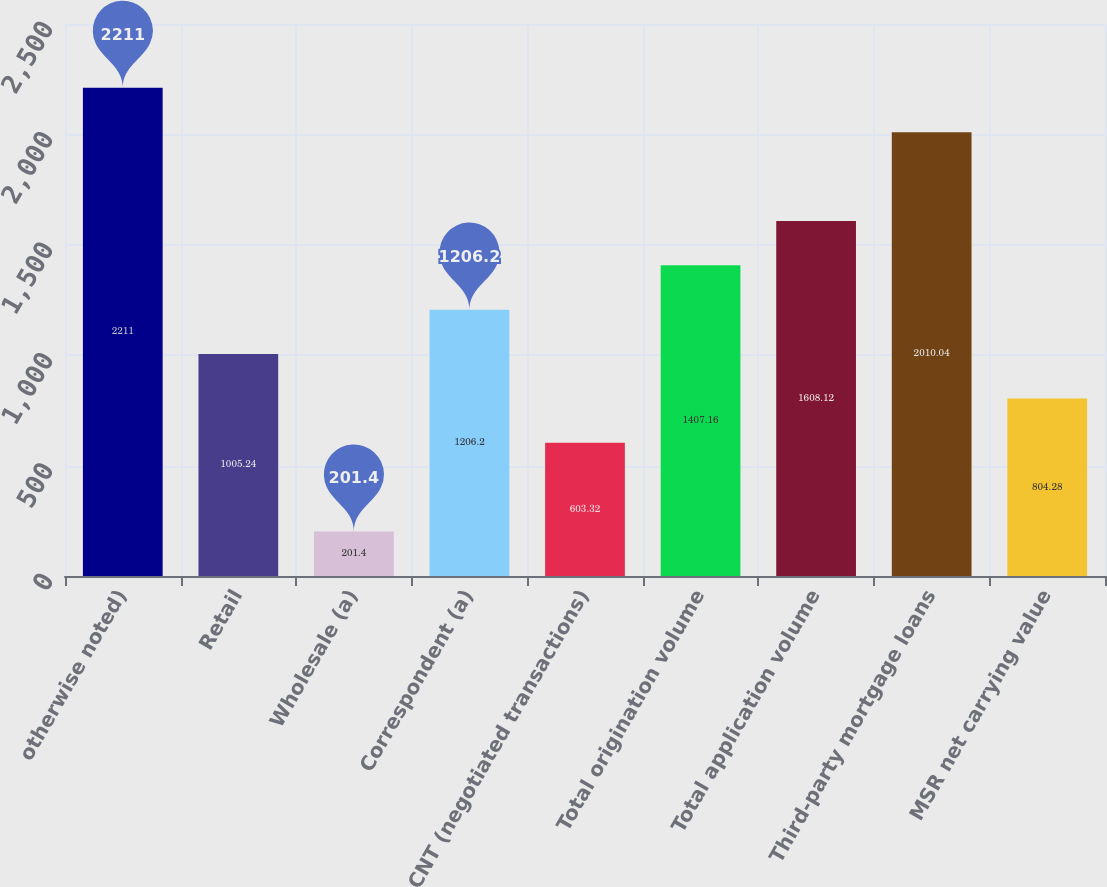Convert chart to OTSL. <chart><loc_0><loc_0><loc_500><loc_500><bar_chart><fcel>otherwise noted)<fcel>Retail<fcel>Wholesale (a)<fcel>Correspondent (a)<fcel>CNT (negotiated transactions)<fcel>Total origination volume<fcel>Total application volume<fcel>Third-party mortgage loans<fcel>MSR net carrying value<nl><fcel>2211<fcel>1005.24<fcel>201.4<fcel>1206.2<fcel>603.32<fcel>1407.16<fcel>1608.12<fcel>2010.04<fcel>804.28<nl></chart> 